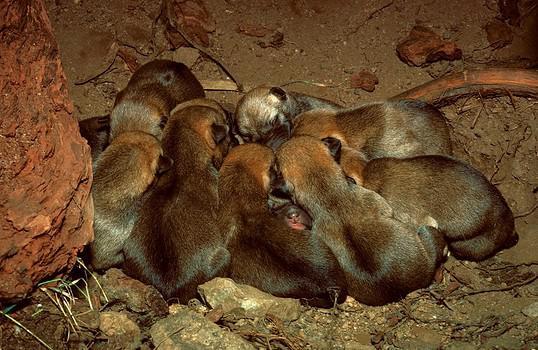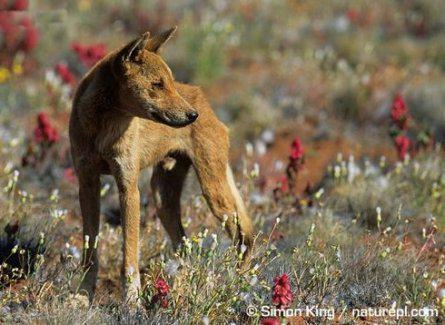The first image is the image on the left, the second image is the image on the right. Considering the images on both sides, is "One of the dingo images includes a natural body of water, and the other features a dog standing upright in the foreground." valid? Answer yes or no. No. The first image is the image on the left, the second image is the image on the right. For the images shown, is this caption "The right image shows at least one wild dog with a prey in its mouth." true? Answer yes or no. No. 